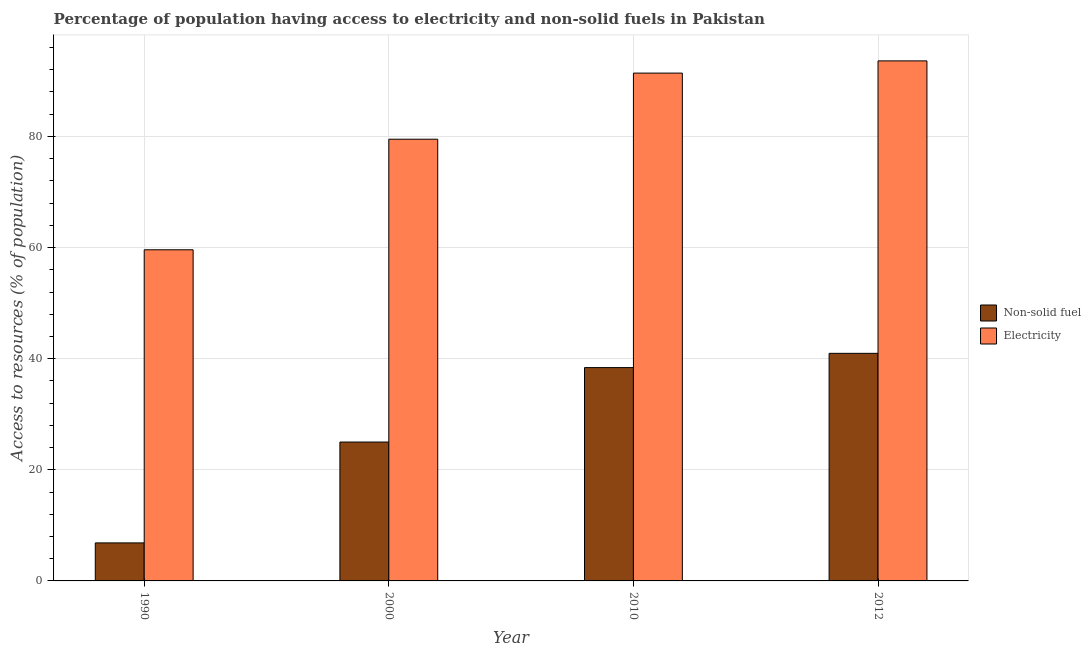Are the number of bars per tick equal to the number of legend labels?
Your answer should be compact. Yes. How many bars are there on the 1st tick from the right?
Provide a succinct answer. 2. In how many cases, is the number of bars for a given year not equal to the number of legend labels?
Offer a terse response. 0. What is the percentage of population having access to electricity in 2010?
Make the answer very short. 91.4. Across all years, what is the maximum percentage of population having access to non-solid fuel?
Your answer should be compact. 40.96. Across all years, what is the minimum percentage of population having access to electricity?
Keep it short and to the point. 59.6. What is the total percentage of population having access to electricity in the graph?
Keep it short and to the point. 324.1. What is the difference between the percentage of population having access to non-solid fuel in 2010 and that in 2012?
Your answer should be compact. -2.57. What is the difference between the percentage of population having access to electricity in 2000 and the percentage of population having access to non-solid fuel in 2012?
Provide a short and direct response. -14.1. What is the average percentage of population having access to electricity per year?
Provide a short and direct response. 81.03. In how many years, is the percentage of population having access to electricity greater than 36 %?
Offer a very short reply. 4. What is the ratio of the percentage of population having access to non-solid fuel in 2010 to that in 2012?
Your answer should be very brief. 0.94. Is the percentage of population having access to non-solid fuel in 2000 less than that in 2010?
Provide a short and direct response. Yes. Is the difference between the percentage of population having access to electricity in 2000 and 2010 greater than the difference between the percentage of population having access to non-solid fuel in 2000 and 2010?
Make the answer very short. No. What is the difference between the highest and the second highest percentage of population having access to electricity?
Ensure brevity in your answer.  2.2. What is the difference between the highest and the lowest percentage of population having access to electricity?
Ensure brevity in your answer.  34. In how many years, is the percentage of population having access to non-solid fuel greater than the average percentage of population having access to non-solid fuel taken over all years?
Give a very brief answer. 2. Is the sum of the percentage of population having access to electricity in 1990 and 2010 greater than the maximum percentage of population having access to non-solid fuel across all years?
Keep it short and to the point. Yes. What does the 1st bar from the left in 2012 represents?
Offer a very short reply. Non-solid fuel. What does the 2nd bar from the right in 2000 represents?
Give a very brief answer. Non-solid fuel. How many years are there in the graph?
Make the answer very short. 4. Are the values on the major ticks of Y-axis written in scientific E-notation?
Ensure brevity in your answer.  No. Does the graph contain any zero values?
Make the answer very short. No. How are the legend labels stacked?
Keep it short and to the point. Vertical. What is the title of the graph?
Offer a very short reply. Percentage of population having access to electricity and non-solid fuels in Pakistan. What is the label or title of the Y-axis?
Your answer should be very brief. Access to resources (% of population). What is the Access to resources (% of population) in Non-solid fuel in 1990?
Provide a short and direct response. 6.84. What is the Access to resources (% of population) of Electricity in 1990?
Provide a succinct answer. 59.6. What is the Access to resources (% of population) of Non-solid fuel in 2000?
Keep it short and to the point. 25. What is the Access to resources (% of population) of Electricity in 2000?
Make the answer very short. 79.5. What is the Access to resources (% of population) of Non-solid fuel in 2010?
Make the answer very short. 38.4. What is the Access to resources (% of population) of Electricity in 2010?
Make the answer very short. 91.4. What is the Access to resources (% of population) in Non-solid fuel in 2012?
Provide a succinct answer. 40.96. What is the Access to resources (% of population) of Electricity in 2012?
Keep it short and to the point. 93.6. Across all years, what is the maximum Access to resources (% of population) of Non-solid fuel?
Offer a terse response. 40.96. Across all years, what is the maximum Access to resources (% of population) in Electricity?
Provide a succinct answer. 93.6. Across all years, what is the minimum Access to resources (% of population) of Non-solid fuel?
Your answer should be very brief. 6.84. Across all years, what is the minimum Access to resources (% of population) of Electricity?
Provide a succinct answer. 59.6. What is the total Access to resources (% of population) of Non-solid fuel in the graph?
Provide a succinct answer. 111.2. What is the total Access to resources (% of population) of Electricity in the graph?
Your answer should be very brief. 324.1. What is the difference between the Access to resources (% of population) in Non-solid fuel in 1990 and that in 2000?
Provide a short and direct response. -18.15. What is the difference between the Access to resources (% of population) in Electricity in 1990 and that in 2000?
Your response must be concise. -19.9. What is the difference between the Access to resources (% of population) in Non-solid fuel in 1990 and that in 2010?
Ensure brevity in your answer.  -31.55. What is the difference between the Access to resources (% of population) in Electricity in 1990 and that in 2010?
Offer a very short reply. -31.8. What is the difference between the Access to resources (% of population) of Non-solid fuel in 1990 and that in 2012?
Your answer should be very brief. -34.12. What is the difference between the Access to resources (% of population) of Electricity in 1990 and that in 2012?
Provide a succinct answer. -34. What is the difference between the Access to resources (% of population) of Non-solid fuel in 2000 and that in 2010?
Make the answer very short. -13.4. What is the difference between the Access to resources (% of population) in Non-solid fuel in 2000 and that in 2012?
Your answer should be very brief. -15.97. What is the difference between the Access to resources (% of population) in Electricity in 2000 and that in 2012?
Provide a succinct answer. -14.1. What is the difference between the Access to resources (% of population) in Non-solid fuel in 2010 and that in 2012?
Offer a terse response. -2.57. What is the difference between the Access to resources (% of population) in Electricity in 2010 and that in 2012?
Your response must be concise. -2.2. What is the difference between the Access to resources (% of population) in Non-solid fuel in 1990 and the Access to resources (% of population) in Electricity in 2000?
Your answer should be compact. -72.66. What is the difference between the Access to resources (% of population) of Non-solid fuel in 1990 and the Access to resources (% of population) of Electricity in 2010?
Your answer should be very brief. -84.56. What is the difference between the Access to resources (% of population) in Non-solid fuel in 1990 and the Access to resources (% of population) in Electricity in 2012?
Your answer should be very brief. -86.76. What is the difference between the Access to resources (% of population) of Non-solid fuel in 2000 and the Access to resources (% of population) of Electricity in 2010?
Offer a terse response. -66.4. What is the difference between the Access to resources (% of population) of Non-solid fuel in 2000 and the Access to resources (% of population) of Electricity in 2012?
Offer a very short reply. -68.6. What is the difference between the Access to resources (% of population) of Non-solid fuel in 2010 and the Access to resources (% of population) of Electricity in 2012?
Keep it short and to the point. -55.2. What is the average Access to resources (% of population) of Non-solid fuel per year?
Provide a short and direct response. 27.8. What is the average Access to resources (% of population) in Electricity per year?
Ensure brevity in your answer.  81.03. In the year 1990, what is the difference between the Access to resources (% of population) in Non-solid fuel and Access to resources (% of population) in Electricity?
Keep it short and to the point. -52.76. In the year 2000, what is the difference between the Access to resources (% of population) in Non-solid fuel and Access to resources (% of population) in Electricity?
Your answer should be very brief. -54.5. In the year 2010, what is the difference between the Access to resources (% of population) in Non-solid fuel and Access to resources (% of population) in Electricity?
Offer a very short reply. -53. In the year 2012, what is the difference between the Access to resources (% of population) of Non-solid fuel and Access to resources (% of population) of Electricity?
Ensure brevity in your answer.  -52.64. What is the ratio of the Access to resources (% of population) of Non-solid fuel in 1990 to that in 2000?
Provide a short and direct response. 0.27. What is the ratio of the Access to resources (% of population) in Electricity in 1990 to that in 2000?
Offer a terse response. 0.75. What is the ratio of the Access to resources (% of population) of Non-solid fuel in 1990 to that in 2010?
Make the answer very short. 0.18. What is the ratio of the Access to resources (% of population) of Electricity in 1990 to that in 2010?
Your answer should be compact. 0.65. What is the ratio of the Access to resources (% of population) in Non-solid fuel in 1990 to that in 2012?
Your answer should be compact. 0.17. What is the ratio of the Access to resources (% of population) in Electricity in 1990 to that in 2012?
Make the answer very short. 0.64. What is the ratio of the Access to resources (% of population) of Non-solid fuel in 2000 to that in 2010?
Make the answer very short. 0.65. What is the ratio of the Access to resources (% of population) of Electricity in 2000 to that in 2010?
Keep it short and to the point. 0.87. What is the ratio of the Access to resources (% of population) in Non-solid fuel in 2000 to that in 2012?
Offer a terse response. 0.61. What is the ratio of the Access to resources (% of population) of Electricity in 2000 to that in 2012?
Ensure brevity in your answer.  0.85. What is the ratio of the Access to resources (% of population) of Non-solid fuel in 2010 to that in 2012?
Your answer should be very brief. 0.94. What is the ratio of the Access to resources (% of population) of Electricity in 2010 to that in 2012?
Give a very brief answer. 0.98. What is the difference between the highest and the second highest Access to resources (% of population) of Non-solid fuel?
Give a very brief answer. 2.57. What is the difference between the highest and the lowest Access to resources (% of population) of Non-solid fuel?
Provide a succinct answer. 34.12. What is the difference between the highest and the lowest Access to resources (% of population) in Electricity?
Offer a terse response. 34. 